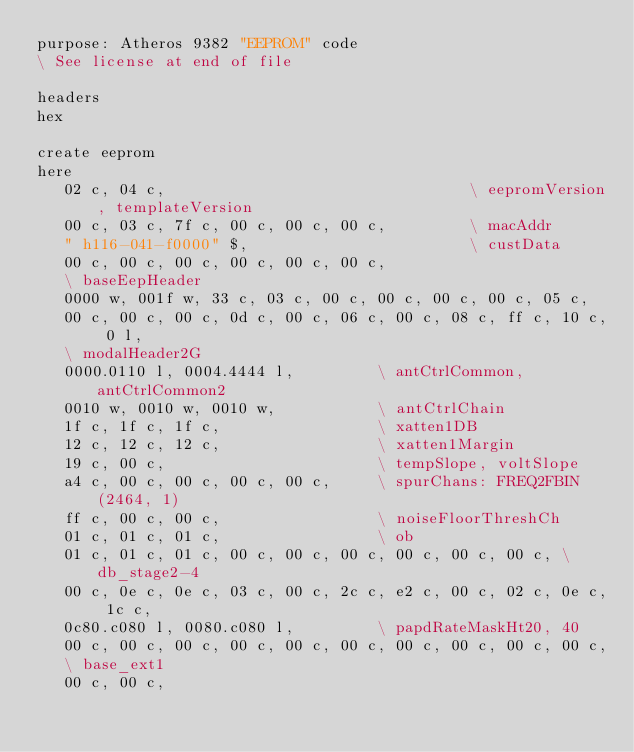Convert code to text. <code><loc_0><loc_0><loc_500><loc_500><_Forth_>purpose: Atheros 9382 "EEPROM" code
\ See license at end of file

headers
hex

create eeprom
here
   02 c, 04 c,                                 \ eepromVersion, templateVersion
   00 c, 03 c, 7f c, 00 c, 00 c, 00 c,         \ macAddr
   " h116-041-f0000" $,                        \ custData
   00 c, 00 c, 00 c, 00 c, 00 c, 00 c,
   \ baseEepHeader
   0000 w, 001f w, 33 c, 03 c, 00 c, 00 c, 00 c, 00 c, 05 c,
   00 c, 00 c, 00 c, 0d c, 00 c, 06 c, 00 c, 08 c, ff c, 10 c, 0 l,
   \ modalHeader2G
   0000.0110 l, 0004.4444 l,         \ antCtrlCommon, antCtrlCommon2
   0010 w, 0010 w, 0010 w,           \ antCtrlChain
   1f c, 1f c, 1f c,                 \ xatten1DB
   12 c, 12 c, 12 c,                 \ xatten1Margin
   19 c, 00 c,                       \ tempSlope, voltSlope
   a4 c, 00 c, 00 c, 00 c, 00 c,     \ spurChans: FREQ2FBIN(2464, 1)
   ff c, 00 c, 00 c,                 \ noiseFloorThreshCh
   01 c, 01 c, 01 c,                 \ ob
   01 c, 01 c, 01 c, 00 c, 00 c, 00 c, 00 c, 00 c, 00 c, \ db_stage2-4
   00 c, 0e c, 0e c, 03 c, 00 c, 2c c, e2 c, 00 c, 02 c, 0e c, 1c c,
   0c80.c080 l, 0080.c080 l,         \ papdRateMaskHt20, 40
   00 c, 00 c, 00 c, 00 c, 00 c, 00 c, 00 c, 00 c, 00 c, 00 c,
   \ base_ext1
   00 c, 00 c,</code> 